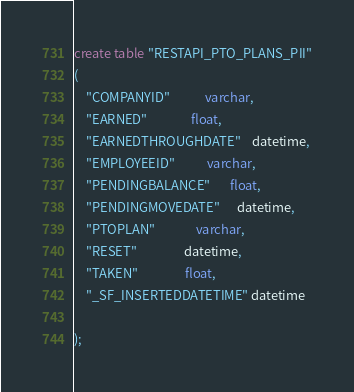Convert code to text. <code><loc_0><loc_0><loc_500><loc_500><_SQL_>create table "RESTAPI_PTO_PLANS_PII"
(
    "COMPANYID"            varchar,
    "EARNED"               float,
    "EARNEDTHROUGHDATE"    datetime,
    "EMPLOYEEID"           varchar,
    "PENDINGBALANCE"       float,
    "PENDINGMOVEDATE"      datetime,
    "PTOPLAN"              varchar,
    "RESET"                datetime,
    "TAKEN"                float,
    "_SF_INSERTEDDATETIME" datetime

);
</code> 